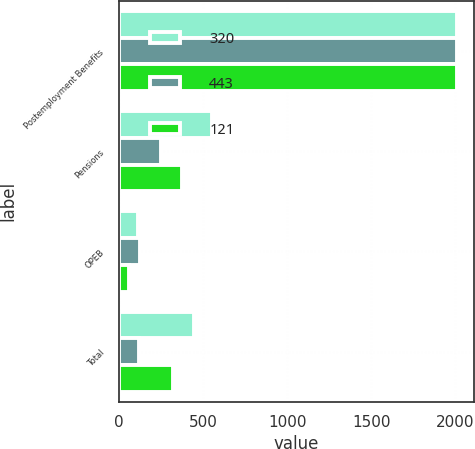<chart> <loc_0><loc_0><loc_500><loc_500><stacked_bar_chart><ecel><fcel>Postemployment Benefits<fcel>Pensions<fcel>OPEB<fcel>Total<nl><fcel>320<fcel>2011<fcel>555<fcel>112<fcel>443<nl><fcel>443<fcel>2010<fcel>247<fcel>126<fcel>121<nl><fcel>121<fcel>2009<fcel>377<fcel>57<fcel>320<nl></chart> 